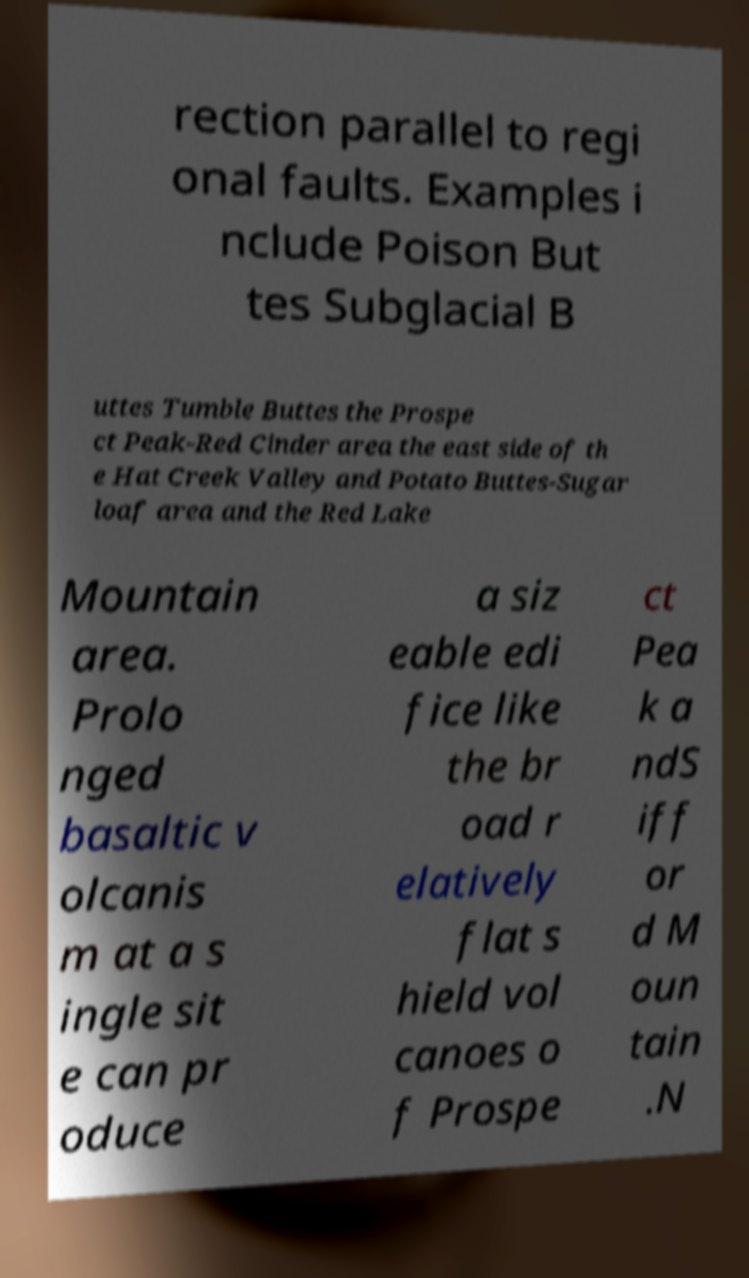I need the written content from this picture converted into text. Can you do that? rection parallel to regi onal faults. Examples i nclude Poison But tes Subglacial B uttes Tumble Buttes the Prospe ct Peak-Red Cinder area the east side of th e Hat Creek Valley and Potato Buttes-Sugar loaf area and the Red Lake Mountain area. Prolo nged basaltic v olcanis m at a s ingle sit e can pr oduce a siz eable edi fice like the br oad r elatively flat s hield vol canoes o f Prospe ct Pea k a ndS iff or d M oun tain .N 